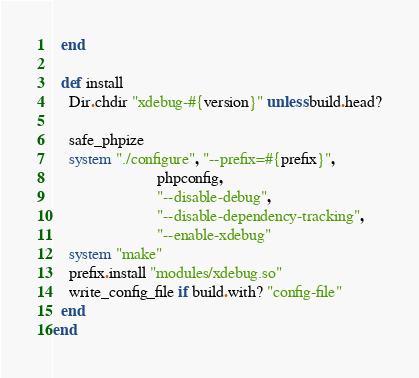<code> <loc_0><loc_0><loc_500><loc_500><_Ruby_>  end

  def install
    Dir.chdir "xdebug-#{version}" unless build.head?

    safe_phpize
    system "./configure", "--prefix=#{prefix}",
                          phpconfig,
                          "--disable-debug",
                          "--disable-dependency-tracking",
                          "--enable-xdebug"
    system "make"
    prefix.install "modules/xdebug.so"
    write_config_file if build.with? "config-file"
  end
end
</code> 